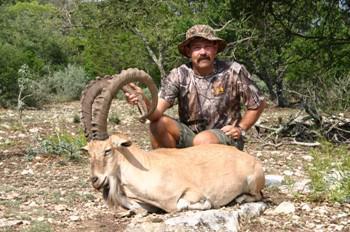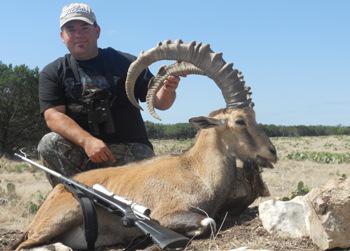The first image is the image on the left, the second image is the image on the right. Examine the images to the left and right. Is the description "An image shows a person in a hat and camo-patterned top posed next to a long-horned animal." accurate? Answer yes or no. Yes. The first image is the image on the left, the second image is the image on the right. Analyze the images presented: Is the assertion "The hunter is near his gun in the image on the right." valid? Answer yes or no. Yes. 